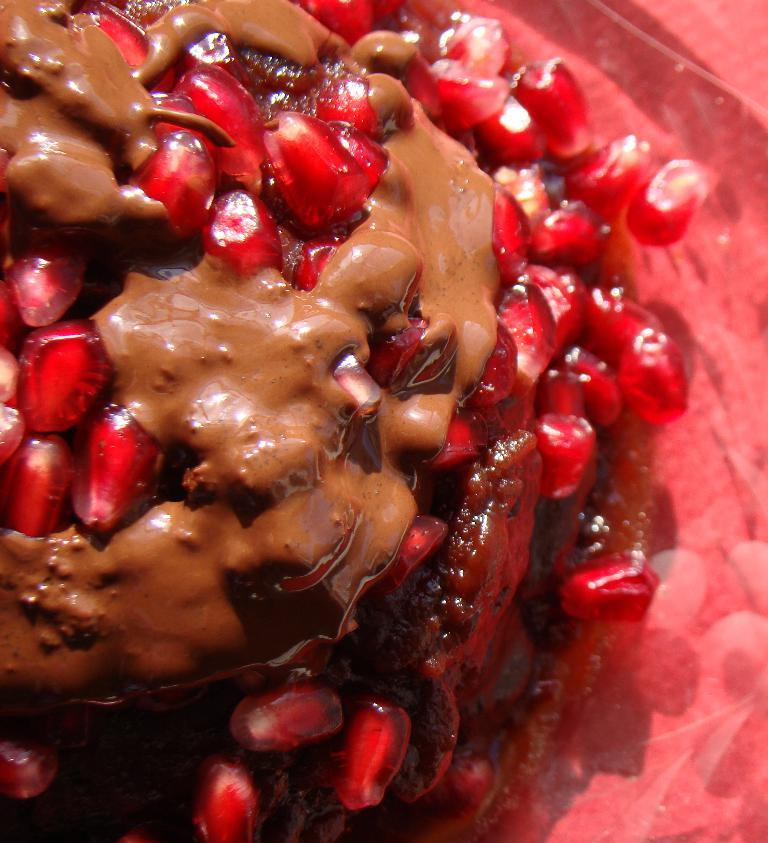What is present on the plate in the image? There is food in a plate in the image. How many times does the beetle fold its wings in the image? There is no beetle present in the image, so it is not possible to answer that question. 